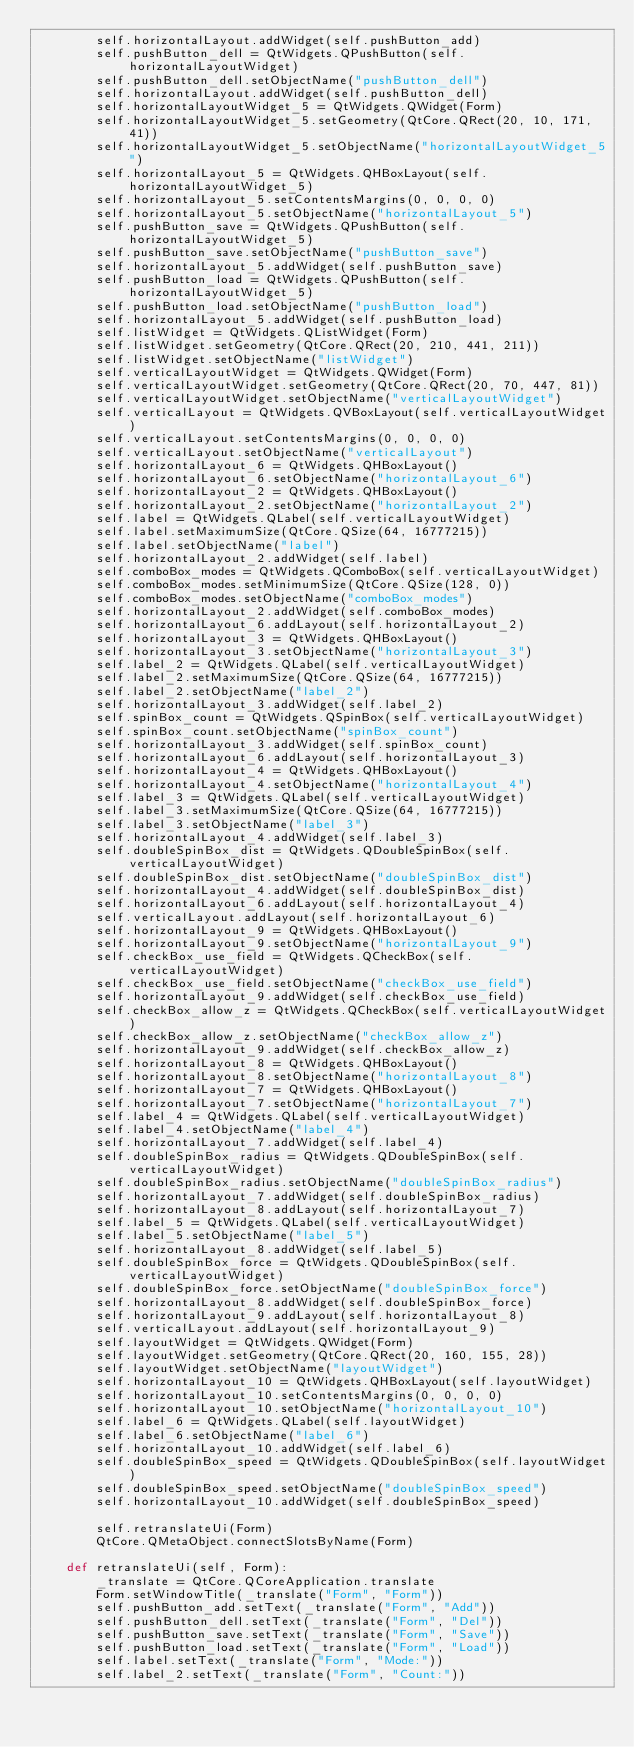Convert code to text. <code><loc_0><loc_0><loc_500><loc_500><_Python_>        self.horizontalLayout.addWidget(self.pushButton_add)
        self.pushButton_dell = QtWidgets.QPushButton(self.horizontalLayoutWidget)
        self.pushButton_dell.setObjectName("pushButton_dell")
        self.horizontalLayout.addWidget(self.pushButton_dell)
        self.horizontalLayoutWidget_5 = QtWidgets.QWidget(Form)
        self.horizontalLayoutWidget_5.setGeometry(QtCore.QRect(20, 10, 171, 41))
        self.horizontalLayoutWidget_5.setObjectName("horizontalLayoutWidget_5")
        self.horizontalLayout_5 = QtWidgets.QHBoxLayout(self.horizontalLayoutWidget_5)
        self.horizontalLayout_5.setContentsMargins(0, 0, 0, 0)
        self.horizontalLayout_5.setObjectName("horizontalLayout_5")
        self.pushButton_save = QtWidgets.QPushButton(self.horizontalLayoutWidget_5)
        self.pushButton_save.setObjectName("pushButton_save")
        self.horizontalLayout_5.addWidget(self.pushButton_save)
        self.pushButton_load = QtWidgets.QPushButton(self.horizontalLayoutWidget_5)
        self.pushButton_load.setObjectName("pushButton_load")
        self.horizontalLayout_5.addWidget(self.pushButton_load)
        self.listWidget = QtWidgets.QListWidget(Form)
        self.listWidget.setGeometry(QtCore.QRect(20, 210, 441, 211))
        self.listWidget.setObjectName("listWidget")
        self.verticalLayoutWidget = QtWidgets.QWidget(Form)
        self.verticalLayoutWidget.setGeometry(QtCore.QRect(20, 70, 447, 81))
        self.verticalLayoutWidget.setObjectName("verticalLayoutWidget")
        self.verticalLayout = QtWidgets.QVBoxLayout(self.verticalLayoutWidget)
        self.verticalLayout.setContentsMargins(0, 0, 0, 0)
        self.verticalLayout.setObjectName("verticalLayout")
        self.horizontalLayout_6 = QtWidgets.QHBoxLayout()
        self.horizontalLayout_6.setObjectName("horizontalLayout_6")
        self.horizontalLayout_2 = QtWidgets.QHBoxLayout()
        self.horizontalLayout_2.setObjectName("horizontalLayout_2")
        self.label = QtWidgets.QLabel(self.verticalLayoutWidget)
        self.label.setMaximumSize(QtCore.QSize(64, 16777215))
        self.label.setObjectName("label")
        self.horizontalLayout_2.addWidget(self.label)
        self.comboBox_modes = QtWidgets.QComboBox(self.verticalLayoutWidget)
        self.comboBox_modes.setMinimumSize(QtCore.QSize(128, 0))
        self.comboBox_modes.setObjectName("comboBox_modes")
        self.horizontalLayout_2.addWidget(self.comboBox_modes)
        self.horizontalLayout_6.addLayout(self.horizontalLayout_2)
        self.horizontalLayout_3 = QtWidgets.QHBoxLayout()
        self.horizontalLayout_3.setObjectName("horizontalLayout_3")
        self.label_2 = QtWidgets.QLabel(self.verticalLayoutWidget)
        self.label_2.setMaximumSize(QtCore.QSize(64, 16777215))
        self.label_2.setObjectName("label_2")
        self.horizontalLayout_3.addWidget(self.label_2)
        self.spinBox_count = QtWidgets.QSpinBox(self.verticalLayoutWidget)
        self.spinBox_count.setObjectName("spinBox_count")
        self.horizontalLayout_3.addWidget(self.spinBox_count)
        self.horizontalLayout_6.addLayout(self.horizontalLayout_3)
        self.horizontalLayout_4 = QtWidgets.QHBoxLayout()
        self.horizontalLayout_4.setObjectName("horizontalLayout_4")
        self.label_3 = QtWidgets.QLabel(self.verticalLayoutWidget)
        self.label_3.setMaximumSize(QtCore.QSize(64, 16777215))
        self.label_3.setObjectName("label_3")
        self.horizontalLayout_4.addWidget(self.label_3)
        self.doubleSpinBox_dist = QtWidgets.QDoubleSpinBox(self.verticalLayoutWidget)
        self.doubleSpinBox_dist.setObjectName("doubleSpinBox_dist")
        self.horizontalLayout_4.addWidget(self.doubleSpinBox_dist)
        self.horizontalLayout_6.addLayout(self.horizontalLayout_4)
        self.verticalLayout.addLayout(self.horizontalLayout_6)
        self.horizontalLayout_9 = QtWidgets.QHBoxLayout()
        self.horizontalLayout_9.setObjectName("horizontalLayout_9")
        self.checkBox_use_field = QtWidgets.QCheckBox(self.verticalLayoutWidget)
        self.checkBox_use_field.setObjectName("checkBox_use_field")
        self.horizontalLayout_9.addWidget(self.checkBox_use_field)
        self.checkBox_allow_z = QtWidgets.QCheckBox(self.verticalLayoutWidget)
        self.checkBox_allow_z.setObjectName("checkBox_allow_z")
        self.horizontalLayout_9.addWidget(self.checkBox_allow_z)
        self.horizontalLayout_8 = QtWidgets.QHBoxLayout()
        self.horizontalLayout_8.setObjectName("horizontalLayout_8")
        self.horizontalLayout_7 = QtWidgets.QHBoxLayout()
        self.horizontalLayout_7.setObjectName("horizontalLayout_7")
        self.label_4 = QtWidgets.QLabel(self.verticalLayoutWidget)
        self.label_4.setObjectName("label_4")
        self.horizontalLayout_7.addWidget(self.label_4)
        self.doubleSpinBox_radius = QtWidgets.QDoubleSpinBox(self.verticalLayoutWidget)
        self.doubleSpinBox_radius.setObjectName("doubleSpinBox_radius")
        self.horizontalLayout_7.addWidget(self.doubleSpinBox_radius)
        self.horizontalLayout_8.addLayout(self.horizontalLayout_7)
        self.label_5 = QtWidgets.QLabel(self.verticalLayoutWidget)
        self.label_5.setObjectName("label_5")
        self.horizontalLayout_8.addWidget(self.label_5)
        self.doubleSpinBox_force = QtWidgets.QDoubleSpinBox(self.verticalLayoutWidget)
        self.doubleSpinBox_force.setObjectName("doubleSpinBox_force")
        self.horizontalLayout_8.addWidget(self.doubleSpinBox_force)
        self.horizontalLayout_9.addLayout(self.horizontalLayout_8)
        self.verticalLayout.addLayout(self.horizontalLayout_9)
        self.layoutWidget = QtWidgets.QWidget(Form)
        self.layoutWidget.setGeometry(QtCore.QRect(20, 160, 155, 28))
        self.layoutWidget.setObjectName("layoutWidget")
        self.horizontalLayout_10 = QtWidgets.QHBoxLayout(self.layoutWidget)
        self.horizontalLayout_10.setContentsMargins(0, 0, 0, 0)
        self.horizontalLayout_10.setObjectName("horizontalLayout_10")
        self.label_6 = QtWidgets.QLabel(self.layoutWidget)
        self.label_6.setObjectName("label_6")
        self.horizontalLayout_10.addWidget(self.label_6)
        self.doubleSpinBox_speed = QtWidgets.QDoubleSpinBox(self.layoutWidget)
        self.doubleSpinBox_speed.setObjectName("doubleSpinBox_speed")
        self.horizontalLayout_10.addWidget(self.doubleSpinBox_speed)

        self.retranslateUi(Form)
        QtCore.QMetaObject.connectSlotsByName(Form)

    def retranslateUi(self, Form):
        _translate = QtCore.QCoreApplication.translate
        Form.setWindowTitle(_translate("Form", "Form"))
        self.pushButton_add.setText(_translate("Form", "Add"))
        self.pushButton_dell.setText(_translate("Form", "Del"))
        self.pushButton_save.setText(_translate("Form", "Save"))
        self.pushButton_load.setText(_translate("Form", "Load"))
        self.label.setText(_translate("Form", "Mode:"))
        self.label_2.setText(_translate("Form", "Count:"))</code> 